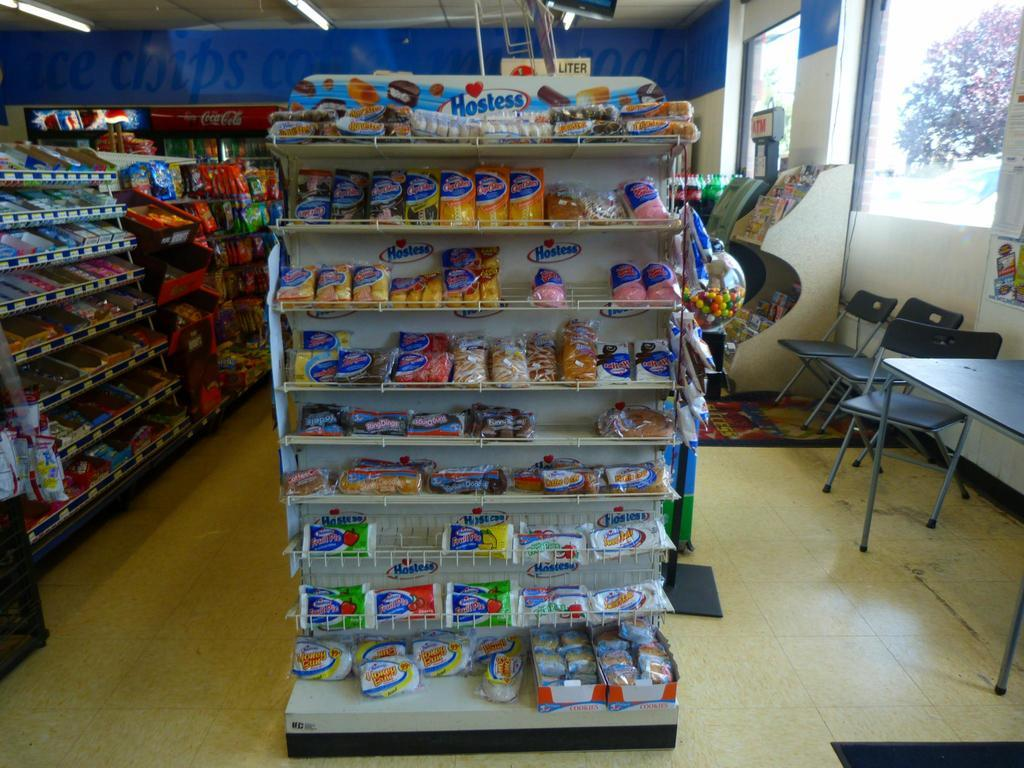<image>
Summarize the visual content of the image. An end unit display in a store for Hostess snacks. 